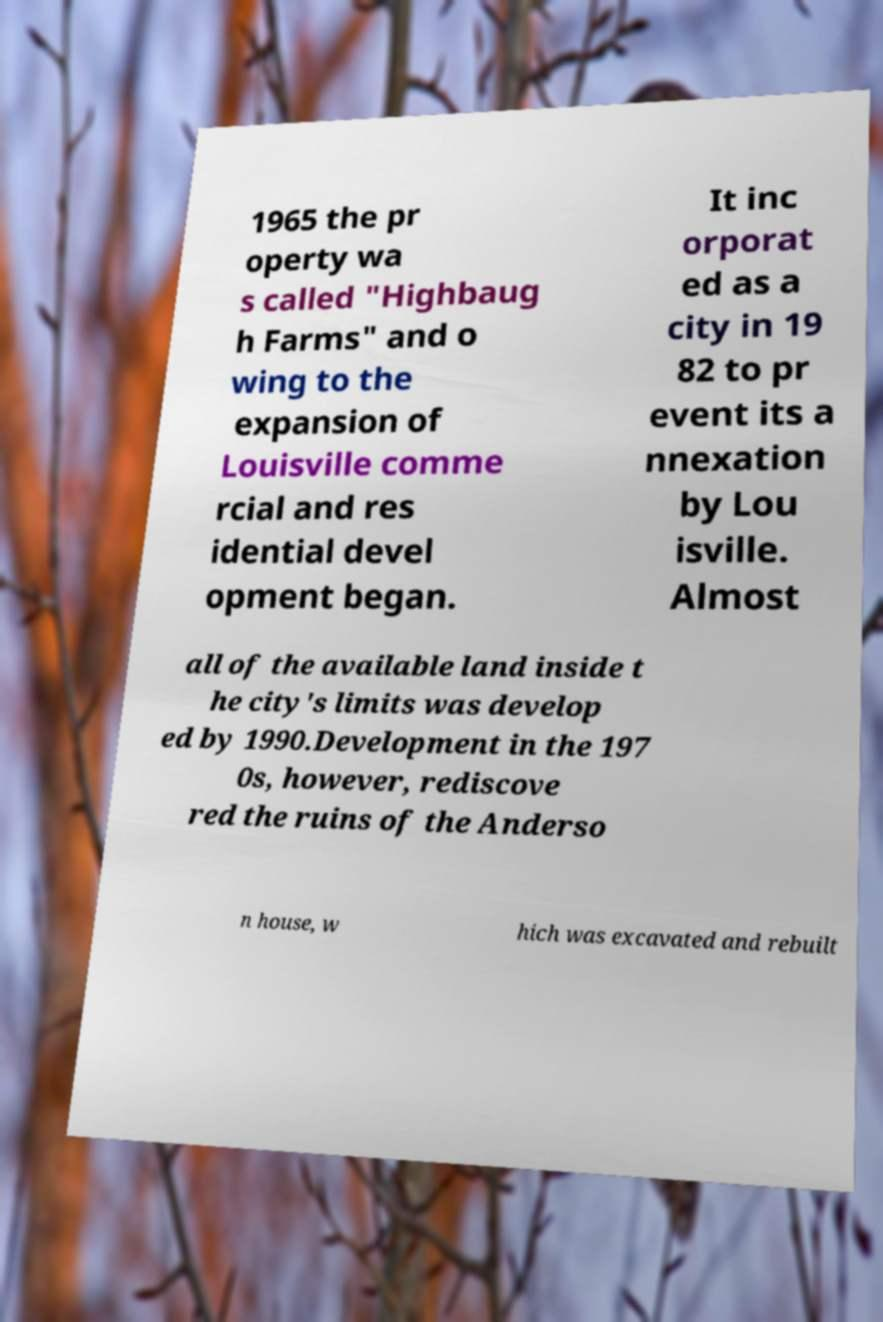I need the written content from this picture converted into text. Can you do that? 1965 the pr operty wa s called "Highbaug h Farms" and o wing to the expansion of Louisville comme rcial and res idential devel opment began. It inc orporat ed as a city in 19 82 to pr event its a nnexation by Lou isville. Almost all of the available land inside t he city's limits was develop ed by 1990.Development in the 197 0s, however, rediscove red the ruins of the Anderso n house, w hich was excavated and rebuilt 